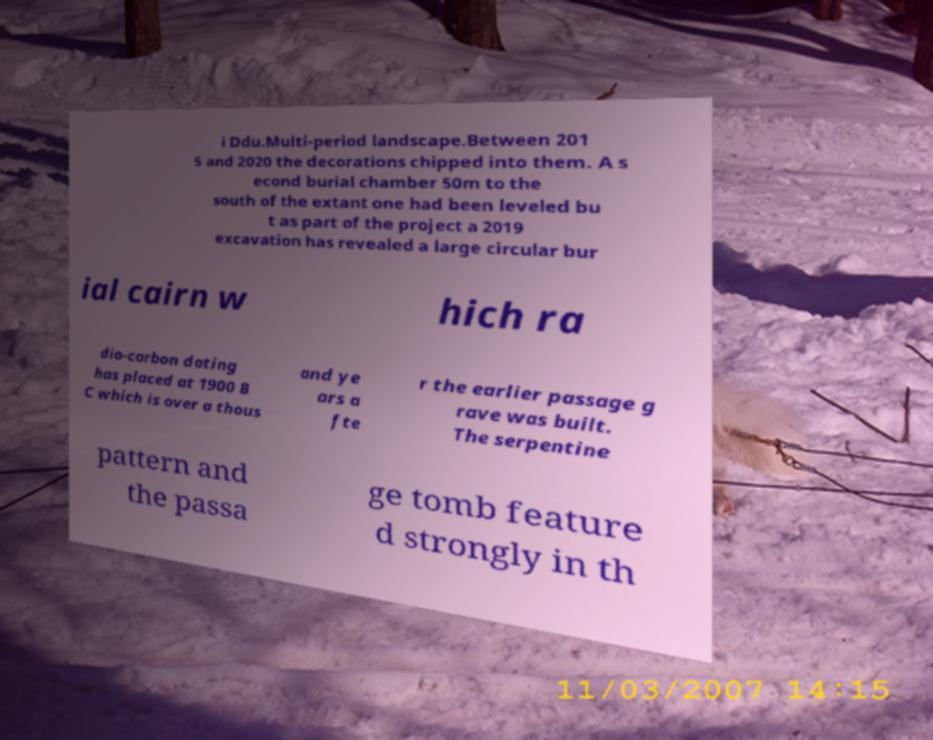Can you read and provide the text displayed in the image?This photo seems to have some interesting text. Can you extract and type it out for me? i Ddu.Multi-period landscape.Between 201 5 and 2020 the decorations chipped into them. A s econd burial chamber 50m to the south of the extant one had been leveled bu t as part of the project a 2019 excavation has revealed a large circular bur ial cairn w hich ra dio-carbon dating has placed at 1900 B C which is over a thous and ye ars a fte r the earlier passage g rave was built. The serpentine pattern and the passa ge tomb feature d strongly in th 